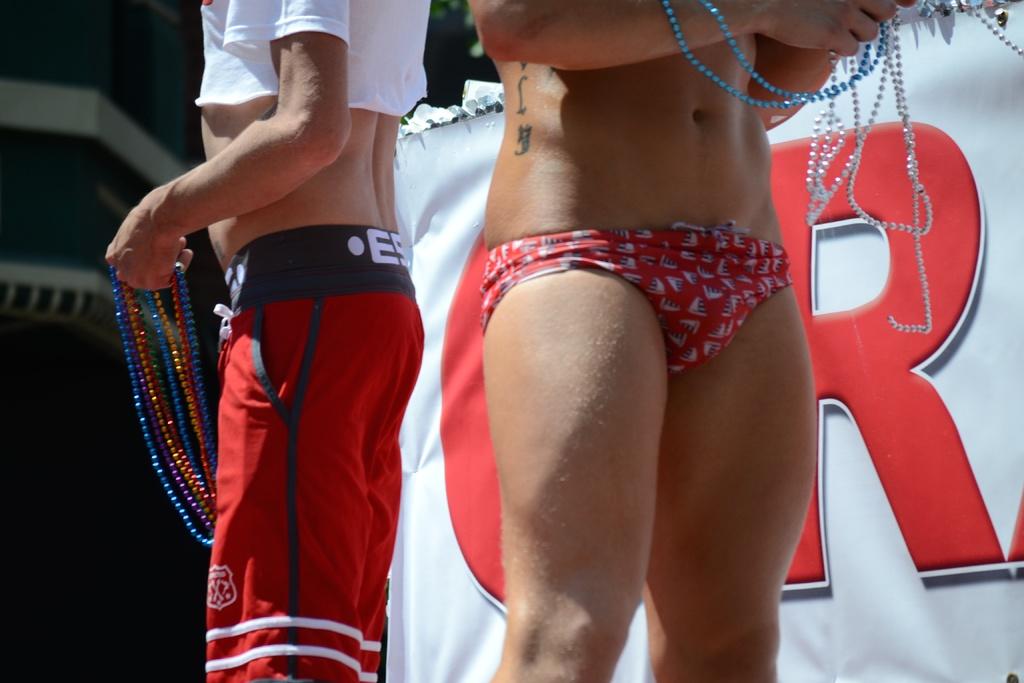What letter is behind the person in the bikini?
Keep it short and to the point. R. 